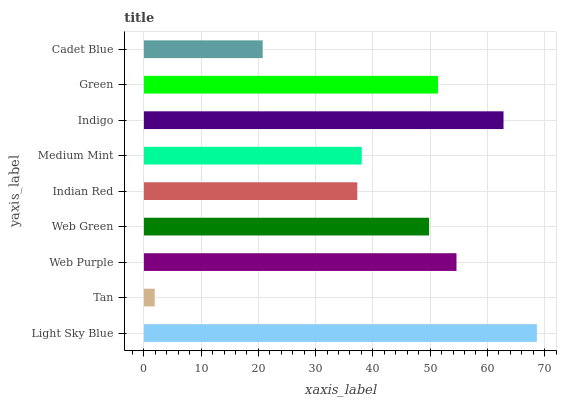Is Tan the minimum?
Answer yes or no. Yes. Is Light Sky Blue the maximum?
Answer yes or no. Yes. Is Web Purple the minimum?
Answer yes or no. No. Is Web Purple the maximum?
Answer yes or no. No. Is Web Purple greater than Tan?
Answer yes or no. Yes. Is Tan less than Web Purple?
Answer yes or no. Yes. Is Tan greater than Web Purple?
Answer yes or no. No. Is Web Purple less than Tan?
Answer yes or no. No. Is Web Green the high median?
Answer yes or no. Yes. Is Web Green the low median?
Answer yes or no. Yes. Is Indigo the high median?
Answer yes or no. No. Is Green the low median?
Answer yes or no. No. 